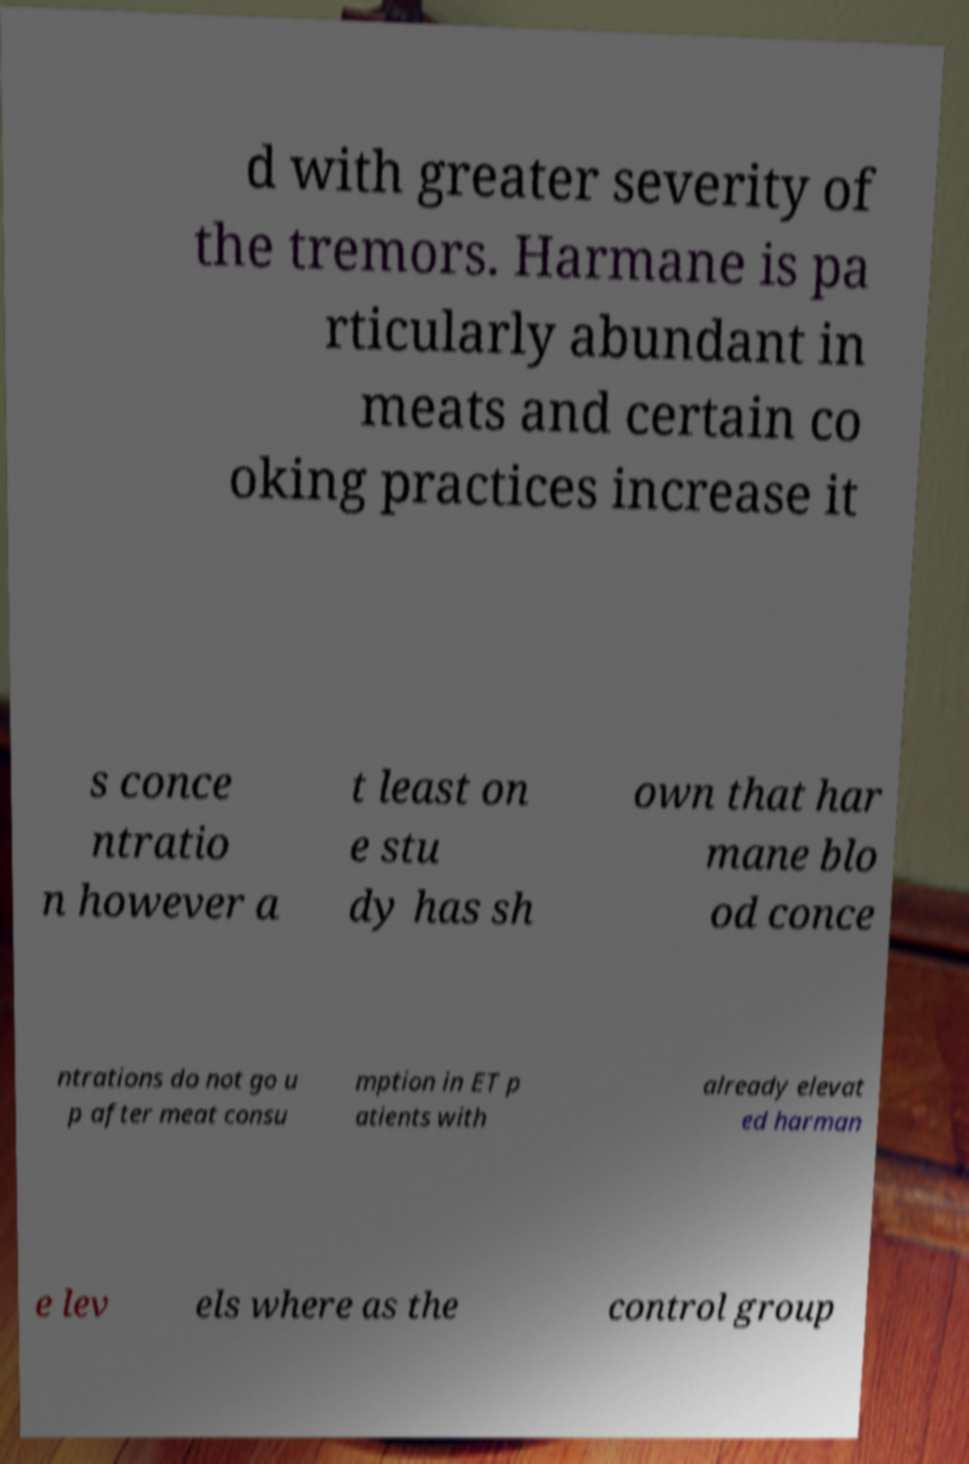There's text embedded in this image that I need extracted. Can you transcribe it verbatim? d with greater severity of the tremors. Harmane is pa rticularly abundant in meats and certain co oking practices increase it s conce ntratio n however a t least on e stu dy has sh own that har mane blo od conce ntrations do not go u p after meat consu mption in ET p atients with already elevat ed harman e lev els where as the control group 